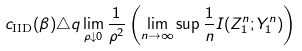Convert formula to latex. <formula><loc_0><loc_0><loc_500><loc_500>c _ { \text {IID} } ( \beta ) \triangle q \lim _ { \rho \downarrow 0 } \frac { 1 } { \rho ^ { 2 } } \left ( \lim _ { n \rightarrow \infty } \sup \frac { 1 } { n } I ( Z _ { 1 } ^ { n } ; Y _ { 1 } ^ { n } ) \right )</formula> 